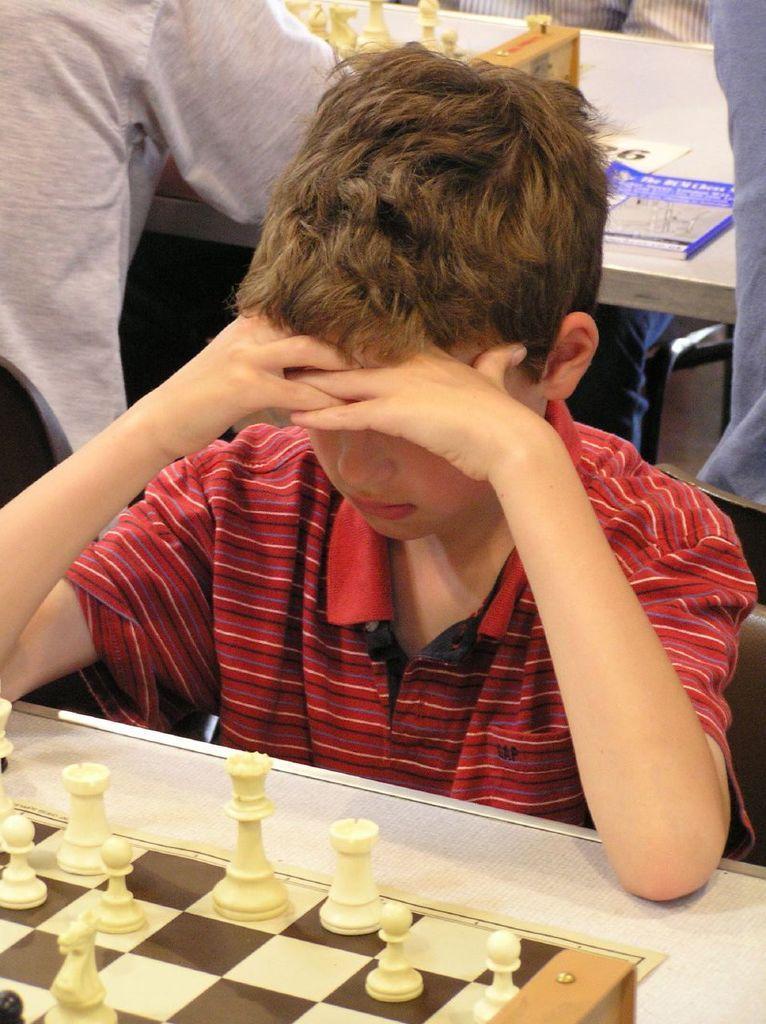Can you describe this image briefly? In this image I can see a person sitting in-front of the chess board. In the back group of people sitting and there are some books on the table. 